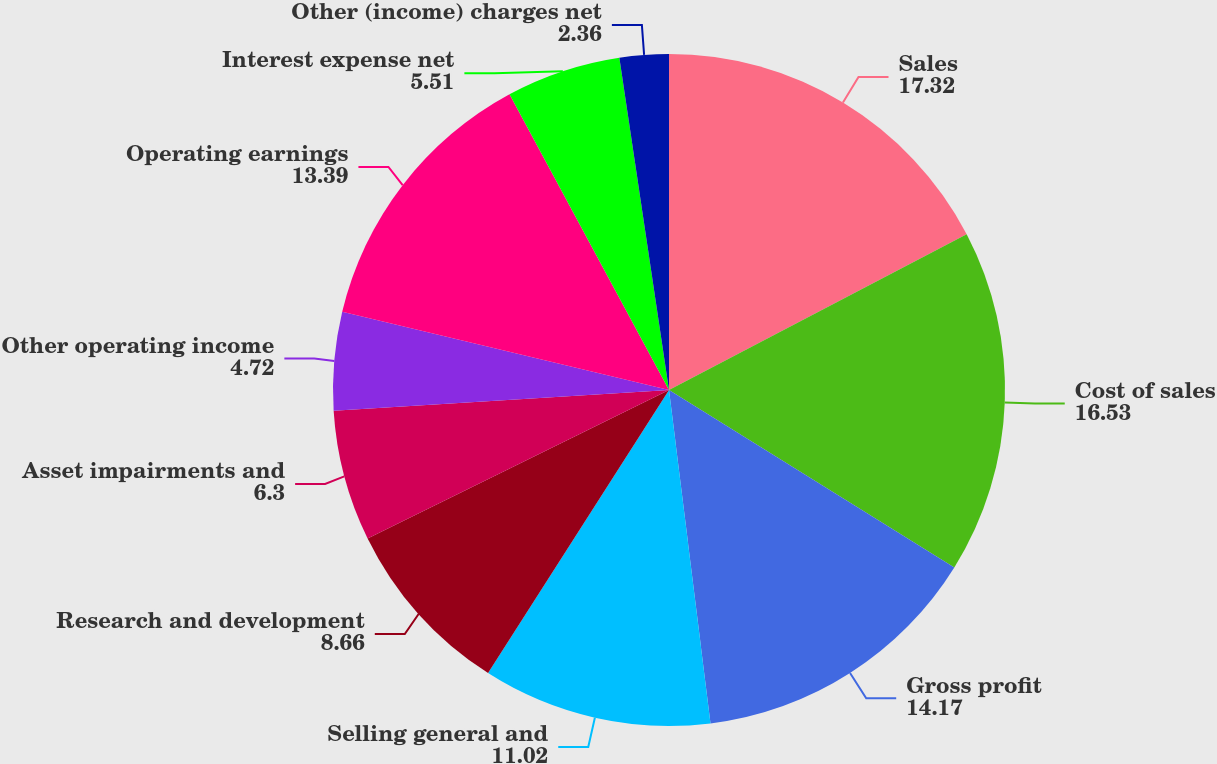<chart> <loc_0><loc_0><loc_500><loc_500><pie_chart><fcel>Sales<fcel>Cost of sales<fcel>Gross profit<fcel>Selling general and<fcel>Research and development<fcel>Asset impairments and<fcel>Other operating income<fcel>Operating earnings<fcel>Interest expense net<fcel>Other (income) charges net<nl><fcel>17.32%<fcel>16.53%<fcel>14.17%<fcel>11.02%<fcel>8.66%<fcel>6.3%<fcel>4.72%<fcel>13.39%<fcel>5.51%<fcel>2.36%<nl></chart> 